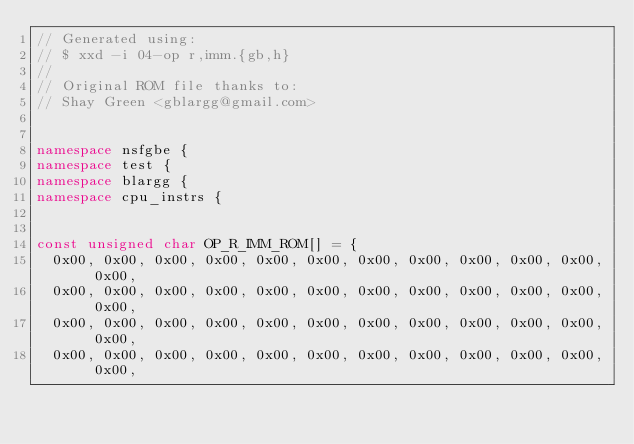Convert code to text. <code><loc_0><loc_0><loc_500><loc_500><_C++_>// Generated using:
// $ xxd -i 04-op r,imm.{gb,h}
//
// Original ROM file thanks to:
// Shay Green <gblargg@gmail.com>


namespace nsfgbe {
namespace test {
namespace blargg {
namespace cpu_instrs {


const unsigned char OP_R_IMM_ROM[] = {
  0x00, 0x00, 0x00, 0x00, 0x00, 0x00, 0x00, 0x00, 0x00, 0x00, 0x00, 0x00,
  0x00, 0x00, 0x00, 0x00, 0x00, 0x00, 0x00, 0x00, 0x00, 0x00, 0x00, 0x00,
  0x00, 0x00, 0x00, 0x00, 0x00, 0x00, 0x00, 0x00, 0x00, 0x00, 0x00, 0x00,
  0x00, 0x00, 0x00, 0x00, 0x00, 0x00, 0x00, 0x00, 0x00, 0x00, 0x00, 0x00,</code> 